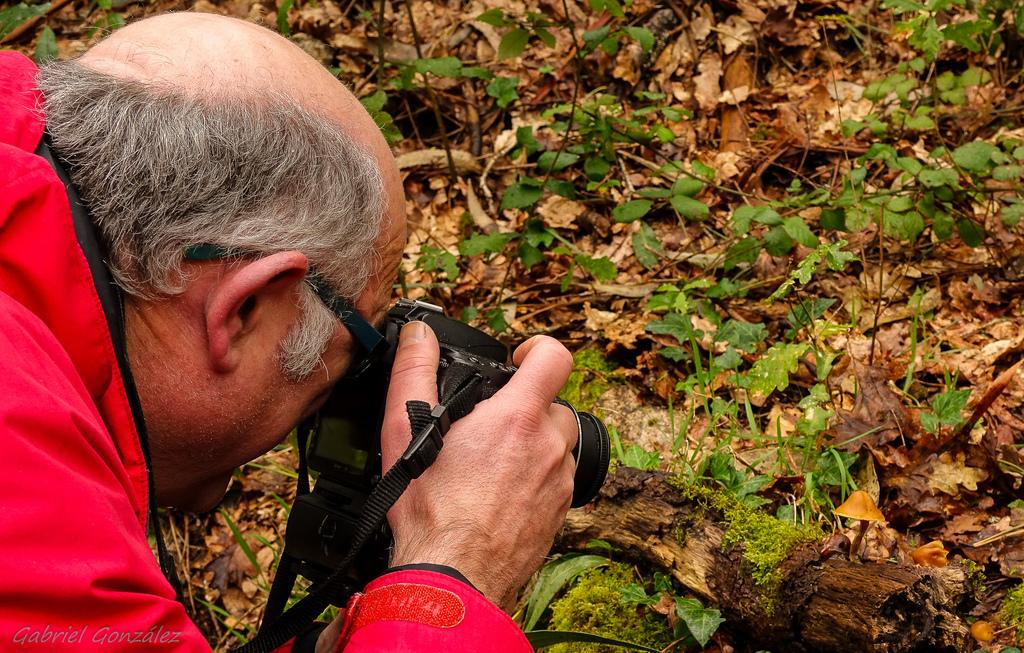What is the main subject of the image? There is a man in the image. Can you describe the man's appearance? The man is wearing clothes and spectacles. What is the man holding in his hand? The man is holding a camera in his hand. What type of natural elements can be seen in the image? There are dry leaves, a wooden log, and grass in the image. What type of grape is the man eating in the image? There is no grape present in the image, and the man is not eating anything. What type of linen is draped over the wooden log in the image? There is no linen draped over the wooden log in the image; only dry leaves and grass are present near it. 